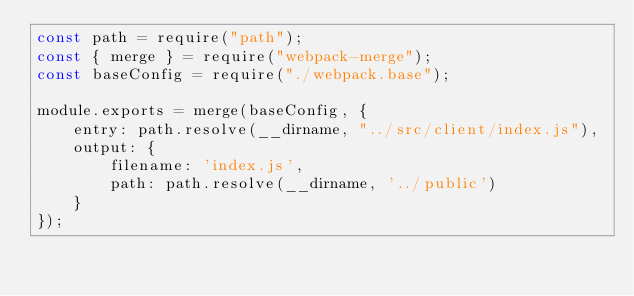Convert code to text. <code><loc_0><loc_0><loc_500><loc_500><_JavaScript_>const path = require("path");
const { merge } = require("webpack-merge");
const baseConfig = require("./webpack.base");

module.exports = merge(baseConfig, {
    entry: path.resolve(__dirname, "../src/client/index.js"),
    output: {
        filename: 'index.js',
        path: path.resolve(__dirname, '../public')
    }
});</code> 